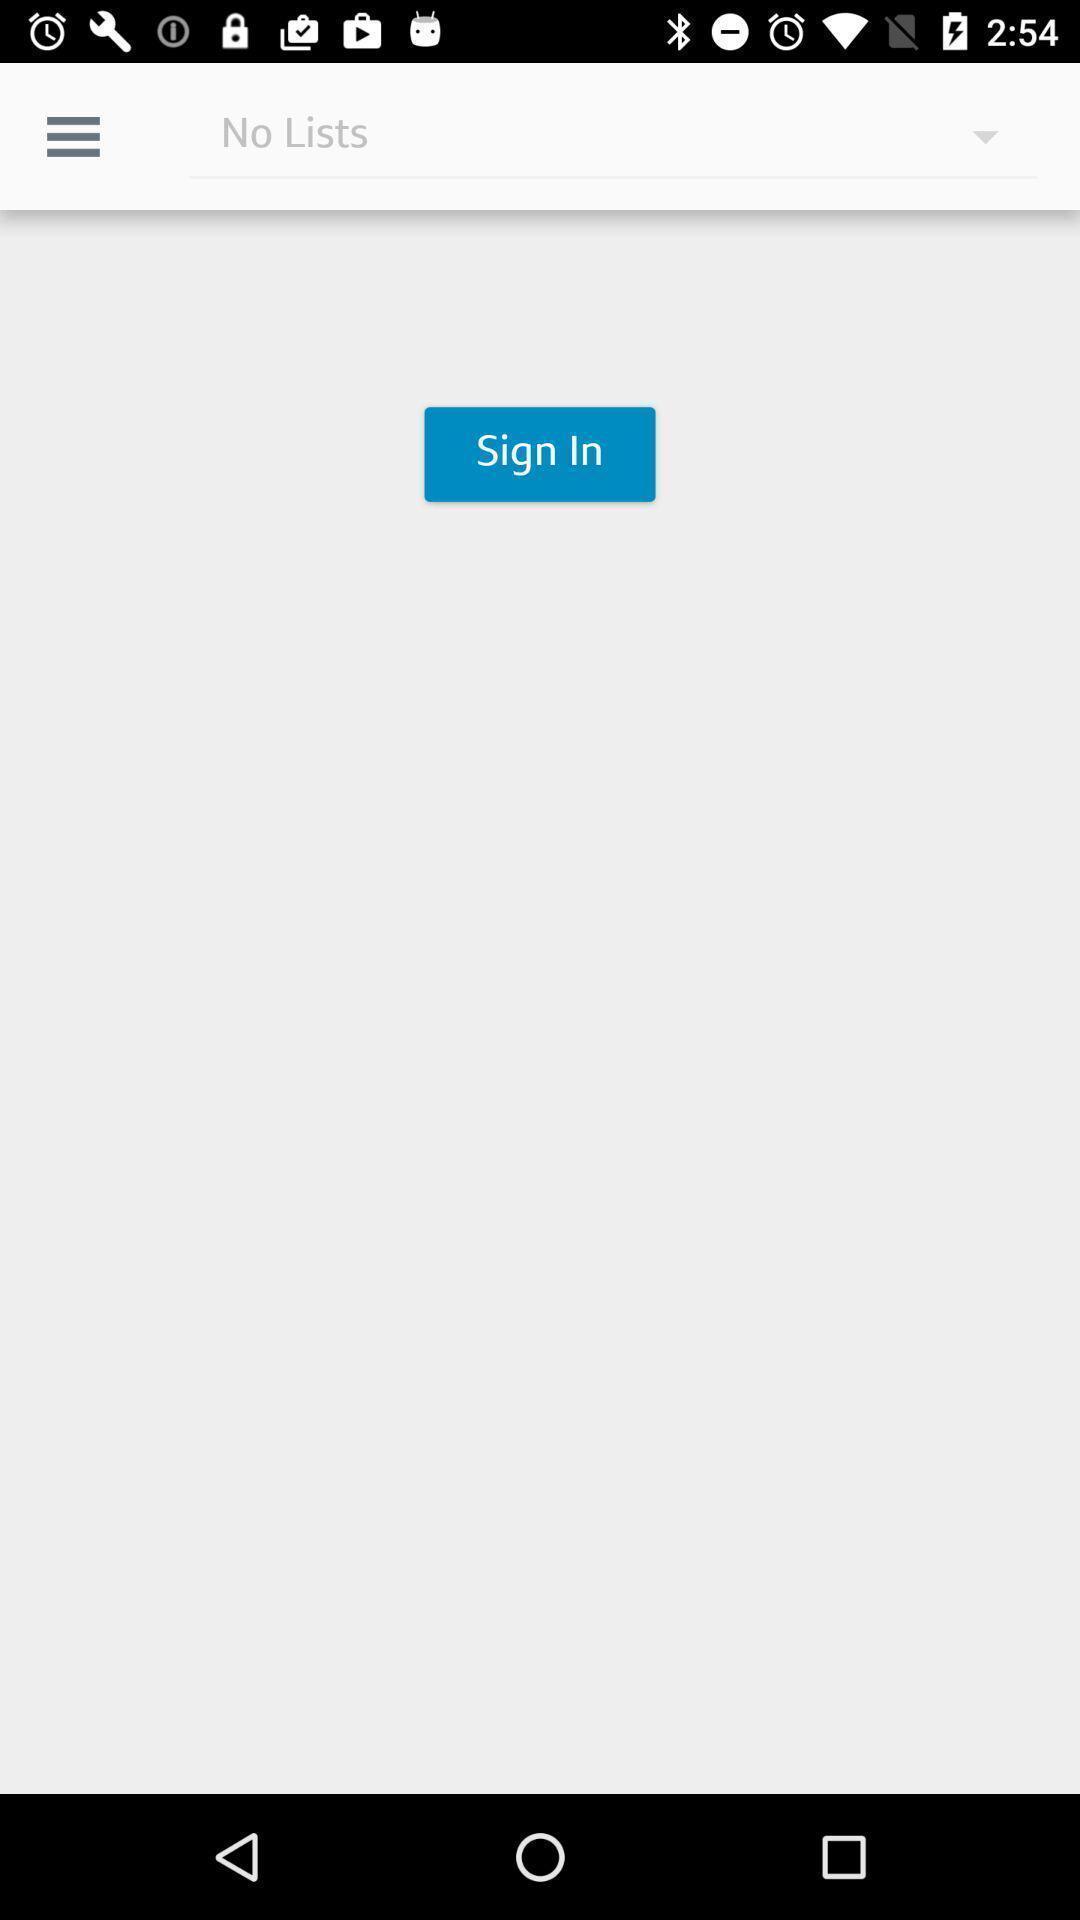Tell me what you see in this picture. Sign in page. 